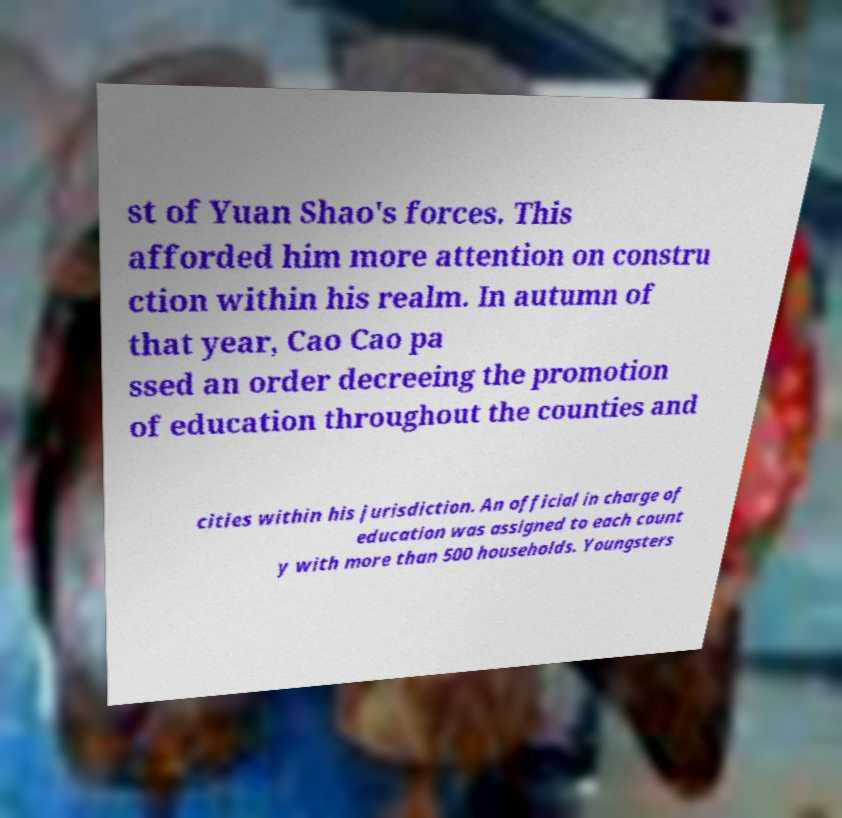Can you read and provide the text displayed in the image?This photo seems to have some interesting text. Can you extract and type it out for me? st of Yuan Shao's forces. This afforded him more attention on constru ction within his realm. In autumn of that year, Cao Cao pa ssed an order decreeing the promotion of education throughout the counties and cities within his jurisdiction. An official in charge of education was assigned to each count y with more than 500 households. Youngsters 